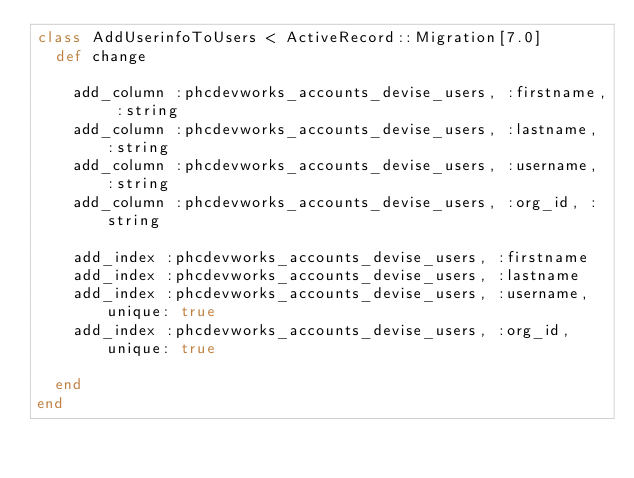Convert code to text. <code><loc_0><loc_0><loc_500><loc_500><_Ruby_>class AddUserinfoToUsers < ActiveRecord::Migration[7.0]
  def change

    add_column :phcdevworks_accounts_devise_users, :firstname, :string
    add_column :phcdevworks_accounts_devise_users, :lastname, :string
    add_column :phcdevworks_accounts_devise_users, :username, :string
    add_column :phcdevworks_accounts_devise_users, :org_id, :string

    add_index :phcdevworks_accounts_devise_users, :firstname
    add_index :phcdevworks_accounts_devise_users, :lastname
    add_index :phcdevworks_accounts_devise_users, :username, unique: true
    add_index :phcdevworks_accounts_devise_users, :org_id, unique: true

  end
end
</code> 